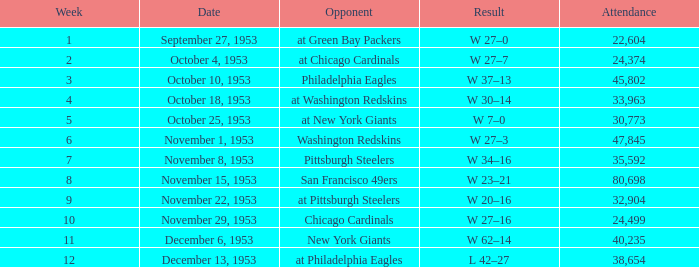What was the maximum number of spectators at a chicago cardinals game after the season's week 10? None. 